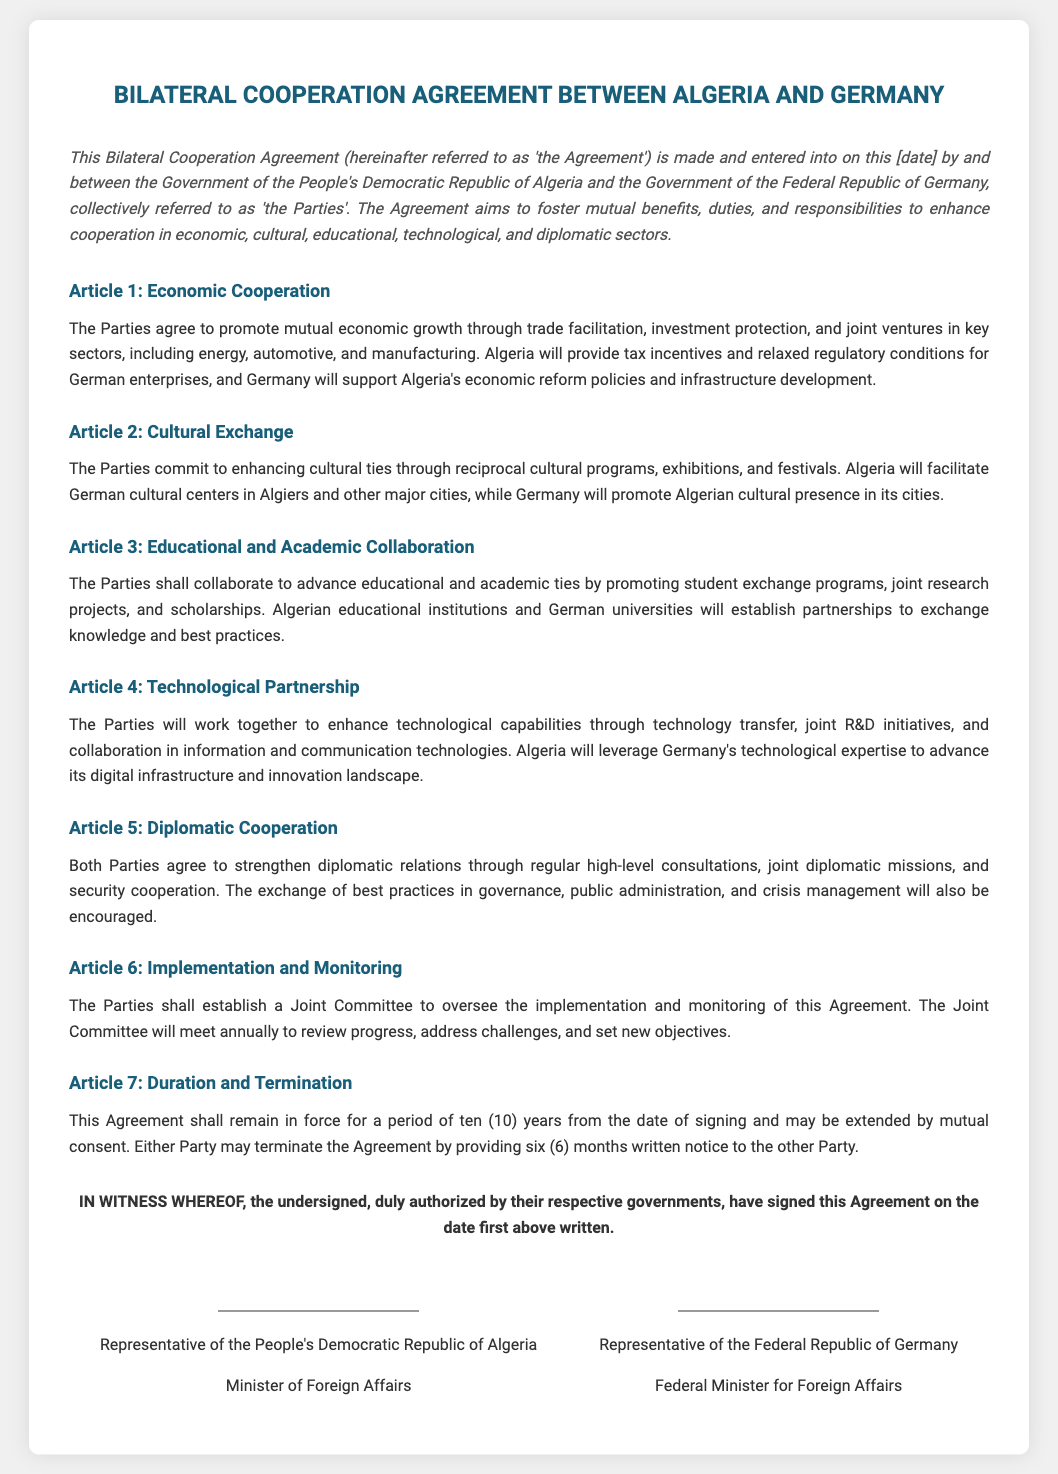What is the title of the document? The title of the document is mentioned in the header section of the Agreement, indicating the focus of the content.
Answer: Bilateral Cooperation Agreement between Algeria and Germany What is the duration of the Agreement? The duration is specified in Article 7, where it states how long the Agreement will remain in force.
Answer: ten (10) years What type of cooperation is mentioned in Article 2? The type of cooperation refers to the specific area addressed in Article 2, which discusses mutual efforts between the parties.
Answer: Cultural Exchange Which country will support Algeria's economic reform policies? The answer is found in Article 1, indicating which party is committed to helping with Algeria's economic reforms.
Answer: Germany Who is responsible for overseeing the implementation of the Agreement? This information can be derived from Article 6, specifying the body set up for monitoring the compliance of the Agreement.
Answer: Joint Committee What should either party provide to terminate the Agreement? This detail is outlined in Article 7, indicating what action needs to be taken if a party wishes to terminate the Agreement.
Answer: six (6) months written notice Which sectors will the Parties focus on for joint ventures? The sectors mentioned in Article 1 signify where the Parties will engage in cooperative business efforts.
Answer: energy, automotive, and manufacturing What will Algeria facilitate in support of cultural ties? This aspect can be found in Article 2, describing what Algeria will establish to enhance cultural programs.
Answer: German cultural centers 